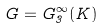Convert formula to latex. <formula><loc_0><loc_0><loc_500><loc_500>G = G _ { 3 } ^ { \infty } ( K )</formula> 